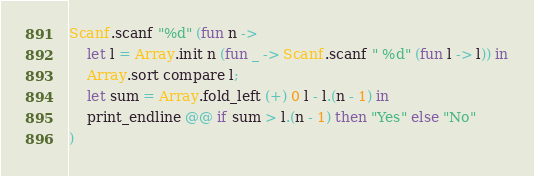<code> <loc_0><loc_0><loc_500><loc_500><_OCaml_>Scanf.scanf "%d" (fun n ->
    let l = Array.init n (fun _ -> Scanf.scanf " %d" (fun l -> l)) in
    Array.sort compare l;
    let sum = Array.fold_left (+) 0 l - l.(n - 1) in
    print_endline @@ if sum > l.(n - 1) then "Yes" else "No"
)</code> 